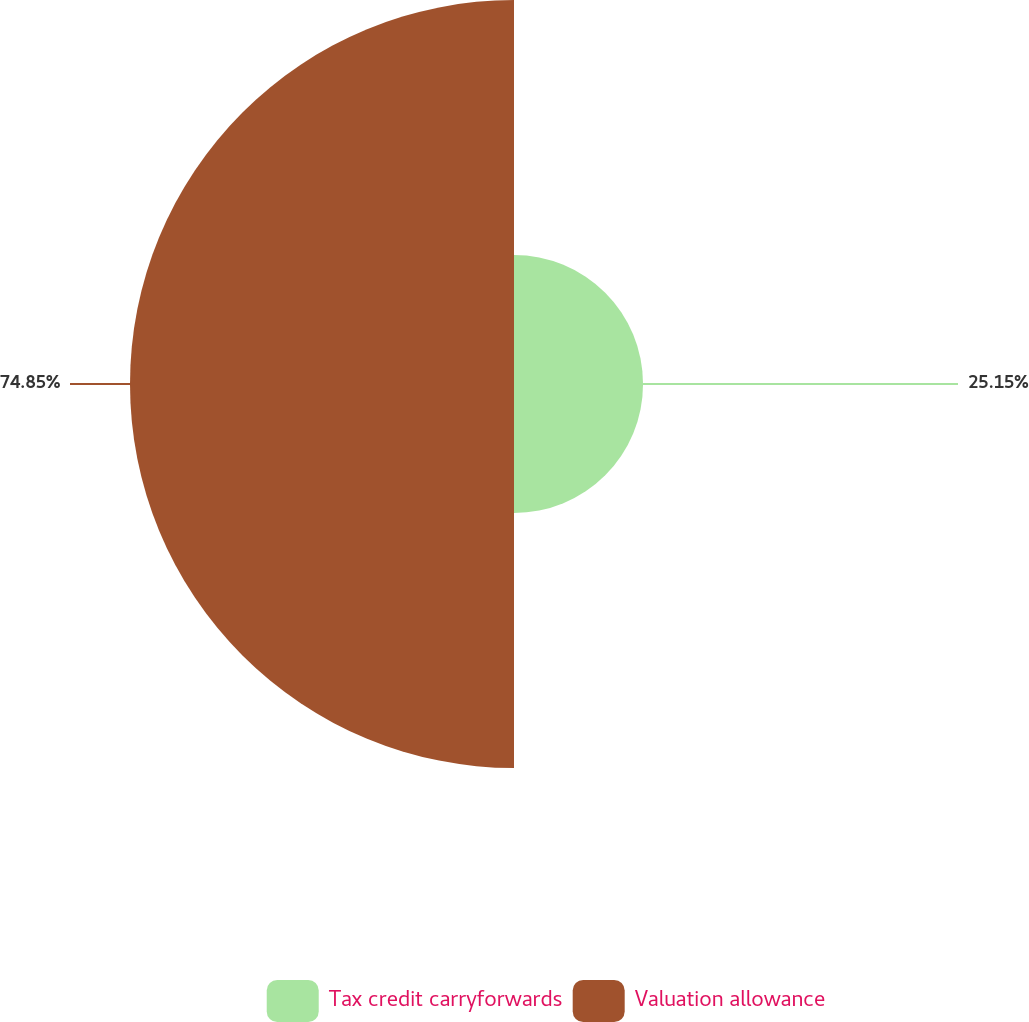<chart> <loc_0><loc_0><loc_500><loc_500><pie_chart><fcel>Tax credit carryforwards<fcel>Valuation allowance<nl><fcel>25.15%<fcel>74.85%<nl></chart> 